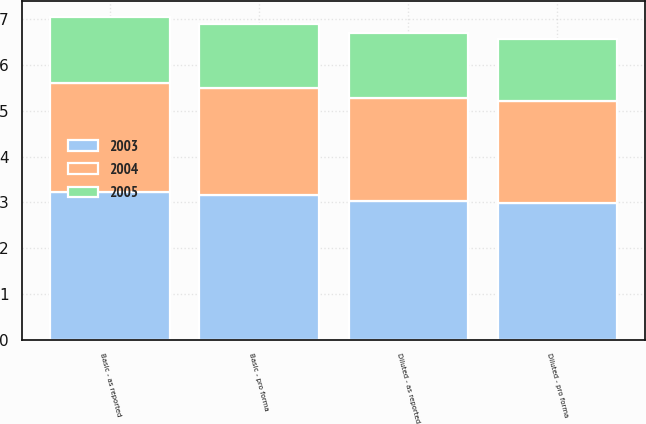Convert chart to OTSL. <chart><loc_0><loc_0><loc_500><loc_500><stacked_bar_chart><ecel><fcel>Basic - as reported<fcel>Basic - pro forma<fcel>Diluted - as reported<fcel>Diluted - pro forma<nl><fcel>2003<fcel>3.22<fcel>3.17<fcel>3.03<fcel>2.99<nl><fcel>2004<fcel>2.39<fcel>2.34<fcel>2.26<fcel>2.22<nl><fcel>2005<fcel>1.45<fcel>1.39<fcel>1.42<fcel>1.36<nl></chart> 